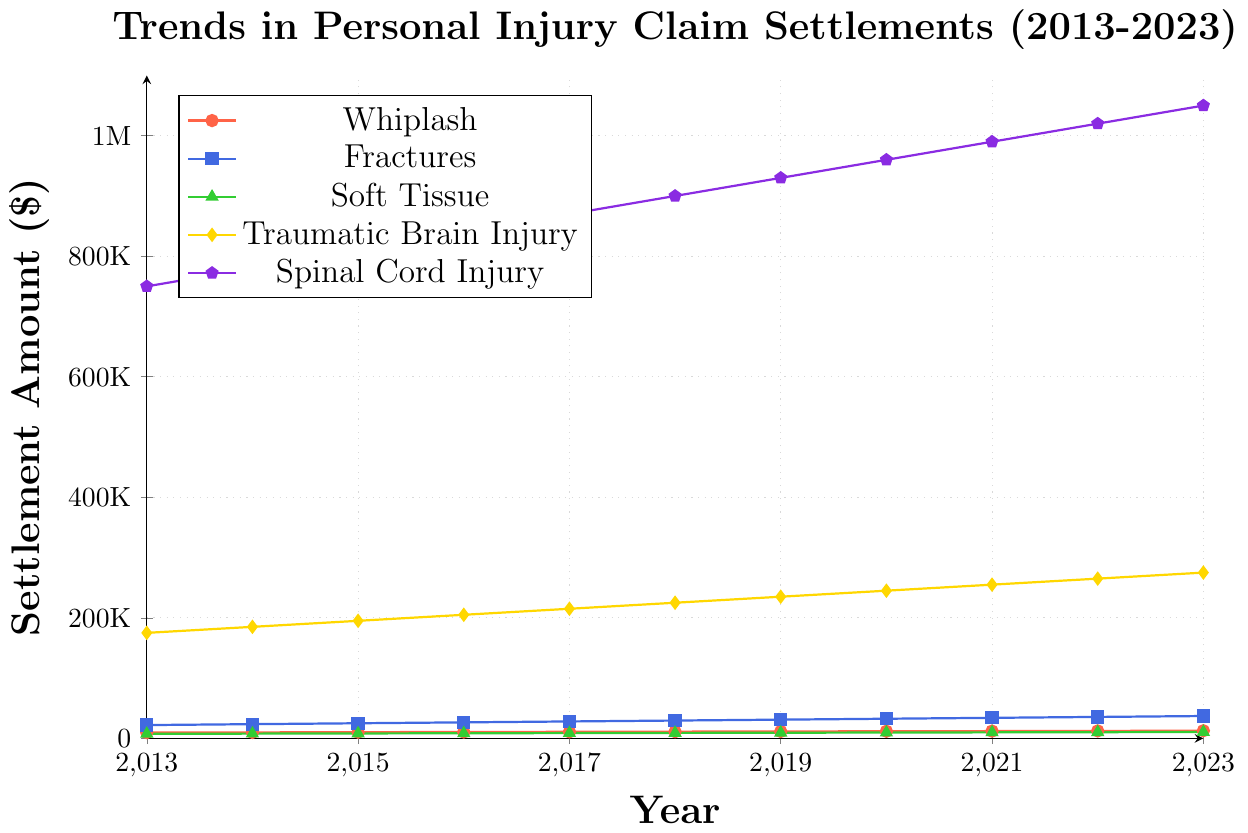How much has the settlement amount for Spinal Cord Injury increased from 2013 to 2023? The settlement amount for Spinal Cord Injury in 2013 was $750,000, and in 2023 it was $1,050,000. The increase is calculated as $1,050,000 - $750,000 = $300,000.
Answer: $300,000 Which injury type saw the highest settlement amount in each year? Spinal Cord Injury had the highest settlement amount in each year. This can be confirmed by visually inspecting the chart and noting that the purple line representing Spinal Cord Injury is consistently the highest.
Answer: Spinal Cord Injury What is the trend in the settlement amount for Whiplash from 2013 to 2023? The settlement amount for Whiplash shows a consistent upward trend from 2013 to 2023. This can be seen by the increasing values along the red line representing Whiplash.
Answer: Upward Trend In which year did the settlement amount for Traumatic Brain Injury exceed $200,000 for the first time? By examining the chart, we see that the yellow line representing Traumatic Brain Injury exceeds $200,000 for the first time in 2016.
Answer: 2016 Compare the settlement amounts for Fractures and Soft Tissue injuries in 2023. Which one is higher? In 2023, the settlement amount for Fractures is $37,000, while for Soft Tissue injuries it is $10,500. The settlement amount for Fractures is higher than that for Soft Tissue injuries.
Answer: Fractures What was the average settlement amount for Traumatic Brain Injury over the decade? To calculate the average, sum the settlement amounts for Traumatic Brain Injury from 2013 to 2023 and divide by the number of years. The amounts are: 175K, 185K, 195K, 205K, 215K, 225K, 235K, 245K, 255K, 265K, and 275K. The sum is 2,475,000, and the average is 2,475,000 / 11 = 225K.
Answer: 225K How does the settlement trend for Soft Tissue injuries compare against Spinal Cord injuries? Soft Tissue injuries show a gradual increase over the years, evident from the green line. However, the steepness of the purple line representing Spinal Cord injuries indicates a much more significant increase in settlements over the same period.
Answer: Less steep increase for Soft Tissue compared to Spinal Cord By how much did the settlement amount for Fractures grow between 2014 and 2020? The settlement amount for Fractures in 2014 was $23,500 and in 2020 it was $32,500. The increase is calculated as $32,500 - $23,500 = $9,000.
Answer: $9,000 What year shows a marked increase in the settlement amount for Whiplash, and by how much did it increase from the previous year? In 2016, the settlement amount for Whiplash increased to $10,500 from $10,200 in 2015, marking an increase of $300.
Answer: 2016, $300 